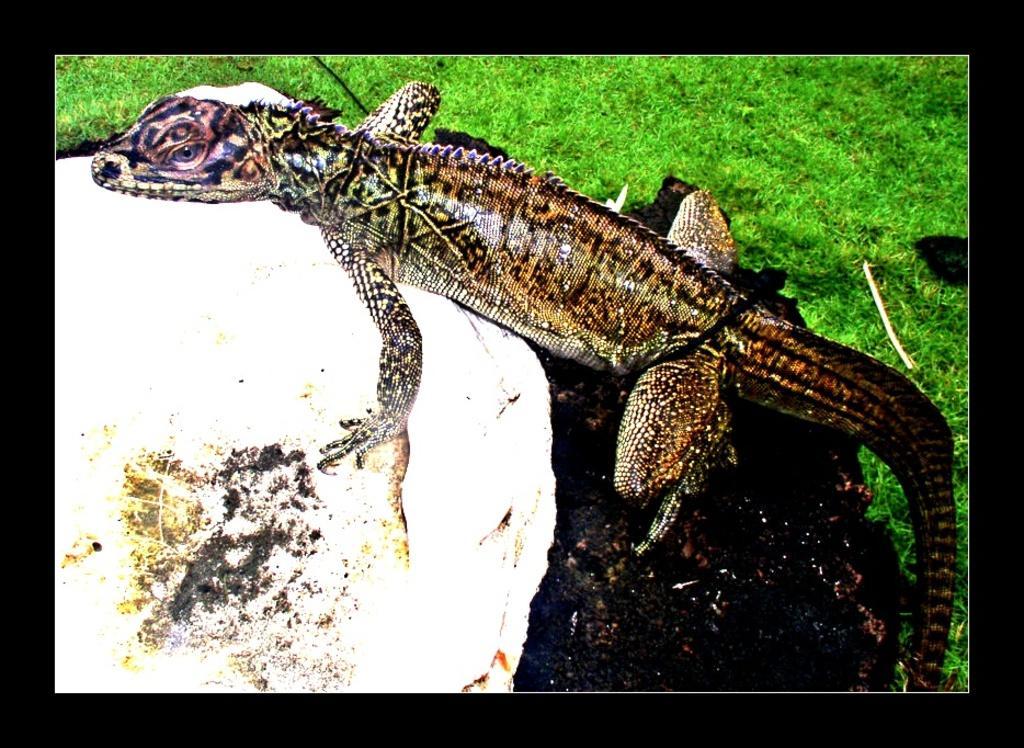Describe this image in one or two sentences. In this image I can see a reptile which is in brown color. Background I can see grass in green color. 